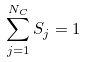Convert formula to latex. <formula><loc_0><loc_0><loc_500><loc_500>\sum _ { j = 1 } ^ { N _ { C } } S _ { j } = 1</formula> 